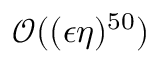<formula> <loc_0><loc_0><loc_500><loc_500>\mathcal { O } ( ( \epsilon \eta ) ^ { 5 0 } )</formula> 